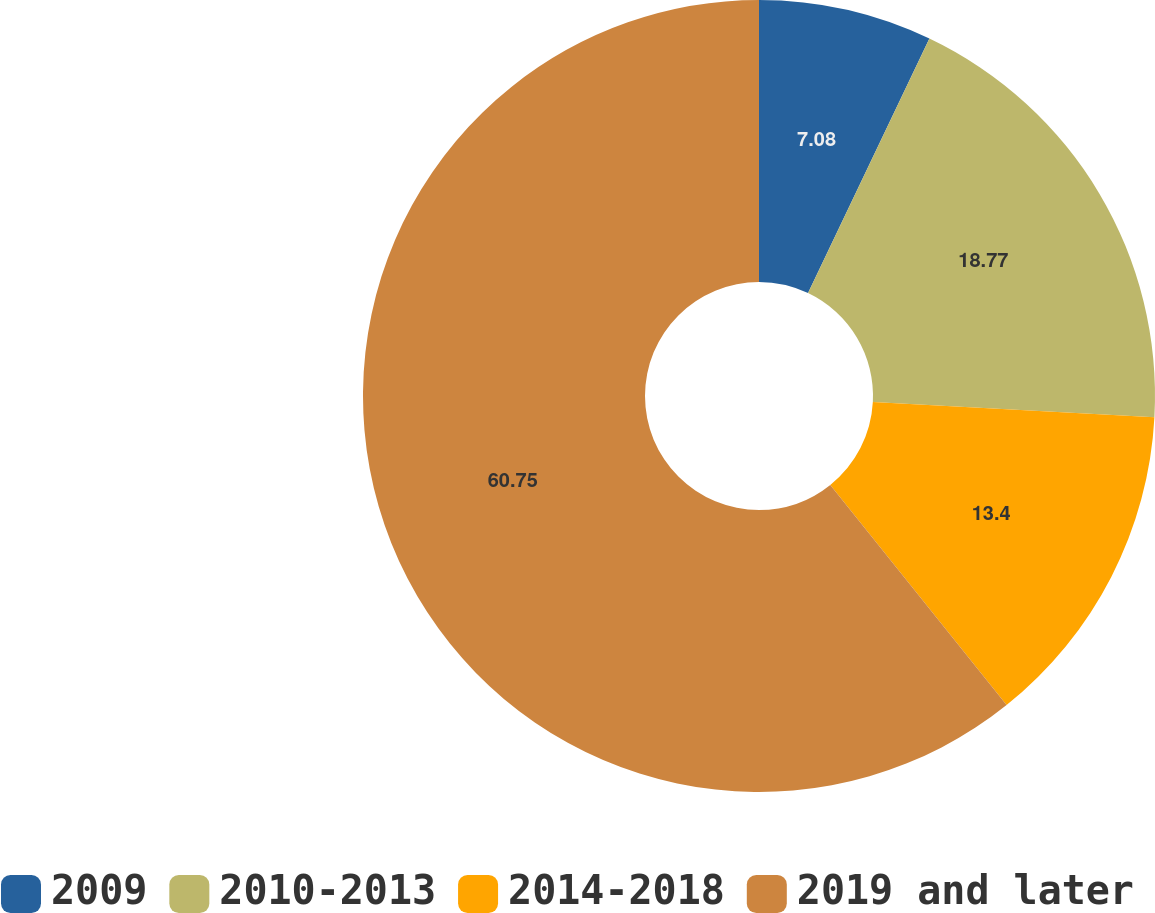Convert chart. <chart><loc_0><loc_0><loc_500><loc_500><pie_chart><fcel>2009<fcel>2010-2013<fcel>2014-2018<fcel>2019 and later<nl><fcel>7.08%<fcel>18.77%<fcel>13.4%<fcel>60.75%<nl></chart> 